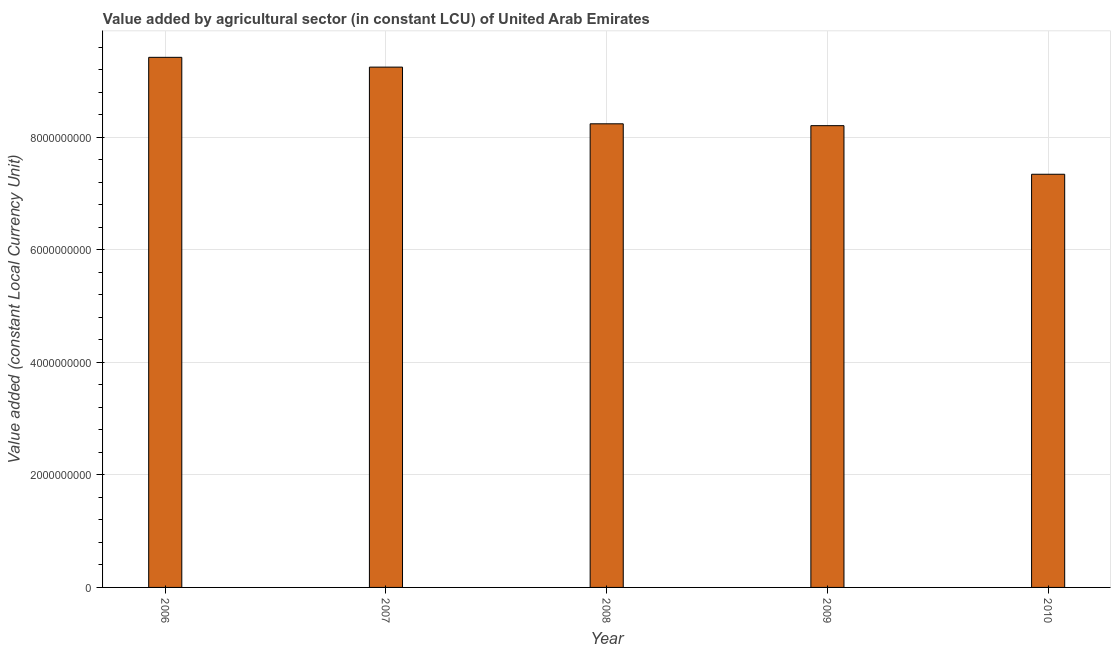Does the graph contain any zero values?
Your response must be concise. No. Does the graph contain grids?
Provide a short and direct response. Yes. What is the title of the graph?
Provide a short and direct response. Value added by agricultural sector (in constant LCU) of United Arab Emirates. What is the label or title of the X-axis?
Your answer should be compact. Year. What is the label or title of the Y-axis?
Your answer should be compact. Value added (constant Local Currency Unit). What is the value added by agriculture sector in 2009?
Your response must be concise. 8.21e+09. Across all years, what is the maximum value added by agriculture sector?
Your response must be concise. 9.42e+09. Across all years, what is the minimum value added by agriculture sector?
Provide a short and direct response. 7.35e+09. In which year was the value added by agriculture sector maximum?
Offer a terse response. 2006. In which year was the value added by agriculture sector minimum?
Your response must be concise. 2010. What is the sum of the value added by agriculture sector?
Make the answer very short. 4.25e+1. What is the difference between the value added by agriculture sector in 2007 and 2010?
Give a very brief answer. 1.90e+09. What is the average value added by agriculture sector per year?
Make the answer very short. 8.50e+09. What is the median value added by agriculture sector?
Your response must be concise. 8.24e+09. What is the ratio of the value added by agriculture sector in 2007 to that in 2010?
Keep it short and to the point. 1.26. What is the difference between the highest and the second highest value added by agriculture sector?
Offer a very short reply. 1.74e+08. Is the sum of the value added by agriculture sector in 2007 and 2010 greater than the maximum value added by agriculture sector across all years?
Ensure brevity in your answer.  Yes. What is the difference between the highest and the lowest value added by agriculture sector?
Offer a very short reply. 2.08e+09. Are all the bars in the graph horizontal?
Provide a short and direct response. No. How many years are there in the graph?
Your answer should be very brief. 5. What is the difference between two consecutive major ticks on the Y-axis?
Offer a very short reply. 2.00e+09. What is the Value added (constant Local Currency Unit) of 2006?
Offer a terse response. 9.42e+09. What is the Value added (constant Local Currency Unit) in 2007?
Offer a very short reply. 9.25e+09. What is the Value added (constant Local Currency Unit) of 2008?
Ensure brevity in your answer.  8.24e+09. What is the Value added (constant Local Currency Unit) of 2009?
Your response must be concise. 8.21e+09. What is the Value added (constant Local Currency Unit) of 2010?
Your response must be concise. 7.35e+09. What is the difference between the Value added (constant Local Currency Unit) in 2006 and 2007?
Offer a very short reply. 1.74e+08. What is the difference between the Value added (constant Local Currency Unit) in 2006 and 2008?
Provide a succinct answer. 1.18e+09. What is the difference between the Value added (constant Local Currency Unit) in 2006 and 2009?
Ensure brevity in your answer.  1.22e+09. What is the difference between the Value added (constant Local Currency Unit) in 2006 and 2010?
Provide a short and direct response. 2.08e+09. What is the difference between the Value added (constant Local Currency Unit) in 2007 and 2008?
Offer a very short reply. 1.01e+09. What is the difference between the Value added (constant Local Currency Unit) in 2007 and 2009?
Provide a succinct answer. 1.04e+09. What is the difference between the Value added (constant Local Currency Unit) in 2007 and 2010?
Keep it short and to the point. 1.90e+09. What is the difference between the Value added (constant Local Currency Unit) in 2008 and 2009?
Offer a terse response. 3.30e+07. What is the difference between the Value added (constant Local Currency Unit) in 2008 and 2010?
Your answer should be very brief. 8.97e+08. What is the difference between the Value added (constant Local Currency Unit) in 2009 and 2010?
Keep it short and to the point. 8.64e+08. What is the ratio of the Value added (constant Local Currency Unit) in 2006 to that in 2008?
Offer a very short reply. 1.14. What is the ratio of the Value added (constant Local Currency Unit) in 2006 to that in 2009?
Make the answer very short. 1.15. What is the ratio of the Value added (constant Local Currency Unit) in 2006 to that in 2010?
Make the answer very short. 1.28. What is the ratio of the Value added (constant Local Currency Unit) in 2007 to that in 2008?
Keep it short and to the point. 1.12. What is the ratio of the Value added (constant Local Currency Unit) in 2007 to that in 2009?
Keep it short and to the point. 1.13. What is the ratio of the Value added (constant Local Currency Unit) in 2007 to that in 2010?
Provide a succinct answer. 1.26. What is the ratio of the Value added (constant Local Currency Unit) in 2008 to that in 2009?
Your answer should be compact. 1. What is the ratio of the Value added (constant Local Currency Unit) in 2008 to that in 2010?
Ensure brevity in your answer.  1.12. What is the ratio of the Value added (constant Local Currency Unit) in 2009 to that in 2010?
Give a very brief answer. 1.12. 